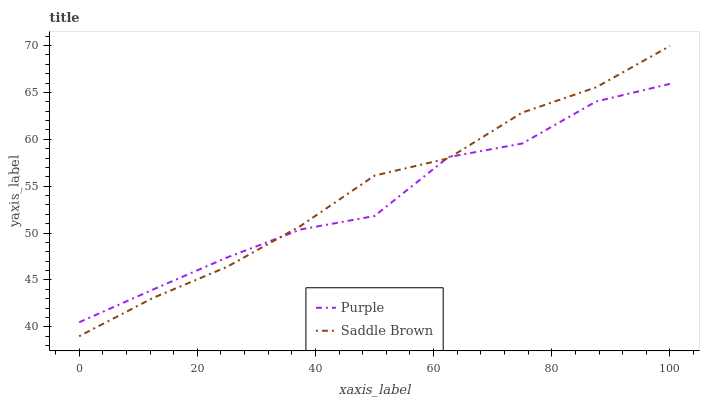Does Saddle Brown have the minimum area under the curve?
Answer yes or no. No. Is Saddle Brown the roughest?
Answer yes or no. No. 